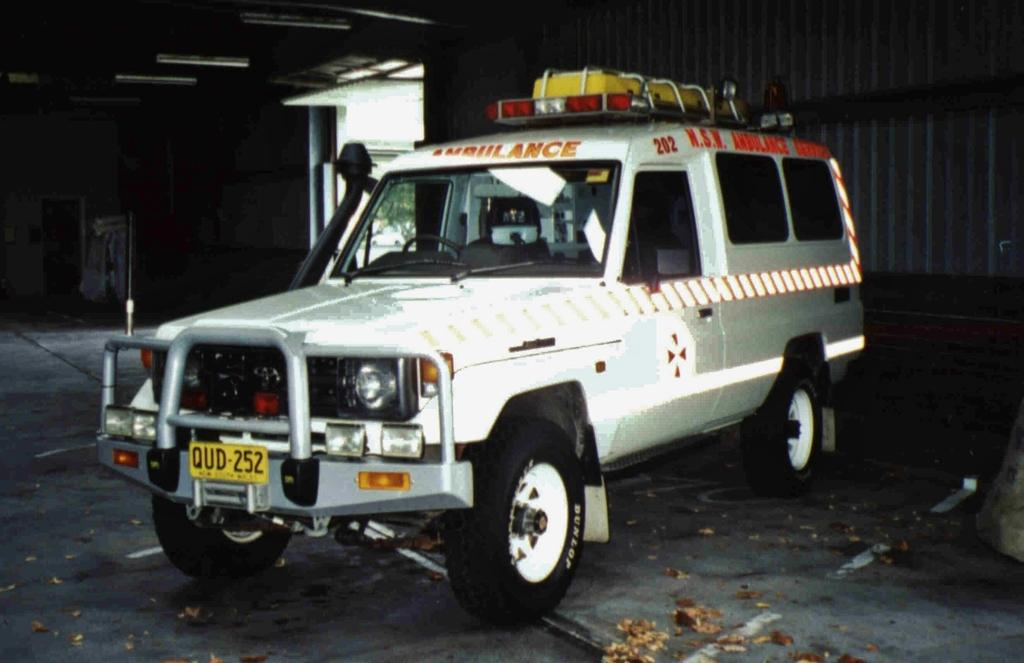What type of space is shown in the image? The image is an inside view of a shed. What can be seen inside the shed? There is a vehicle and objects visible in the image. What is in the background of the image? There is a metal panel and a tree visible in the background of the image. What type of copper bit is used to create the metal panel in the image? There is no copper bit present in the image, nor is there any indication of how the metal panel was created. 